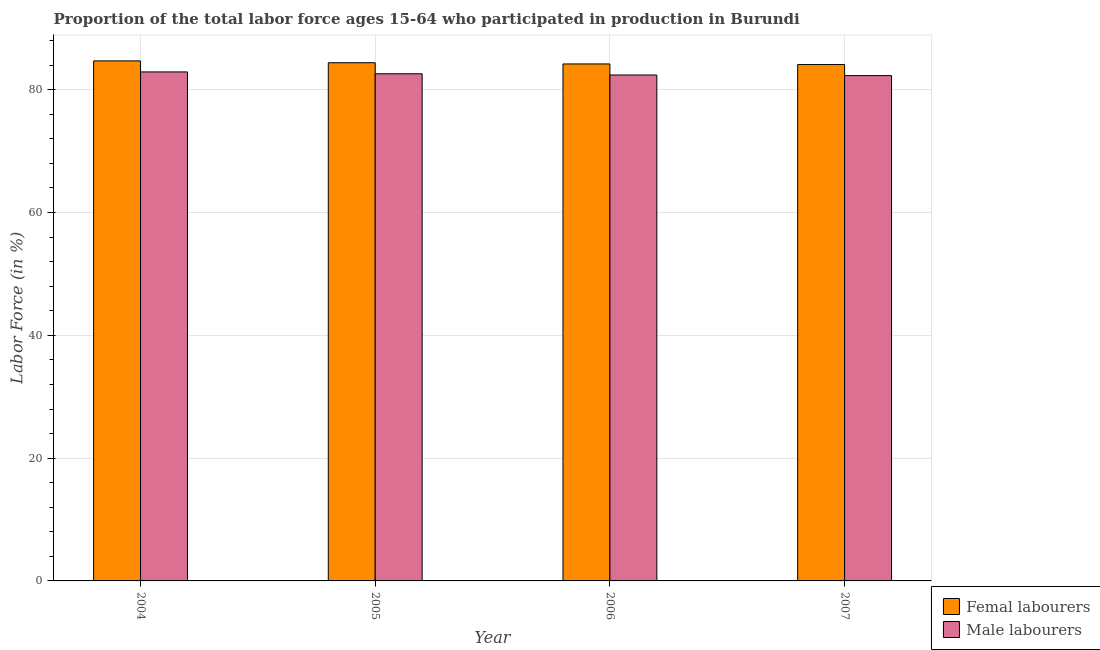Are the number of bars per tick equal to the number of legend labels?
Your answer should be compact. Yes. What is the label of the 4th group of bars from the left?
Provide a succinct answer. 2007. In how many cases, is the number of bars for a given year not equal to the number of legend labels?
Ensure brevity in your answer.  0. What is the percentage of male labour force in 2006?
Your answer should be very brief. 82.4. Across all years, what is the maximum percentage of male labour force?
Your response must be concise. 82.9. Across all years, what is the minimum percentage of female labor force?
Ensure brevity in your answer.  84.1. In which year was the percentage of female labor force maximum?
Your answer should be compact. 2004. What is the total percentage of female labor force in the graph?
Keep it short and to the point. 337.4. What is the difference between the percentage of male labour force in 2004 and that in 2005?
Ensure brevity in your answer.  0.3. What is the difference between the percentage of female labor force in 2006 and the percentage of male labour force in 2004?
Your response must be concise. -0.5. What is the average percentage of female labor force per year?
Ensure brevity in your answer.  84.35. In the year 2007, what is the difference between the percentage of male labour force and percentage of female labor force?
Ensure brevity in your answer.  0. In how many years, is the percentage of female labor force greater than 4 %?
Keep it short and to the point. 4. What is the ratio of the percentage of female labor force in 2004 to that in 2005?
Your response must be concise. 1. Is the percentage of female labor force in 2006 less than that in 2007?
Ensure brevity in your answer.  No. What is the difference between the highest and the second highest percentage of female labor force?
Offer a very short reply. 0.3. What is the difference between the highest and the lowest percentage of female labor force?
Offer a terse response. 0.6. In how many years, is the percentage of male labour force greater than the average percentage of male labour force taken over all years?
Give a very brief answer. 2. Is the sum of the percentage of female labor force in 2004 and 2006 greater than the maximum percentage of male labour force across all years?
Your answer should be compact. Yes. What does the 2nd bar from the left in 2007 represents?
Offer a terse response. Male labourers. What does the 1st bar from the right in 2005 represents?
Your answer should be very brief. Male labourers. How many bars are there?
Your answer should be very brief. 8. Are all the bars in the graph horizontal?
Your answer should be very brief. No. What is the difference between two consecutive major ticks on the Y-axis?
Ensure brevity in your answer.  20. Does the graph contain any zero values?
Ensure brevity in your answer.  No. How are the legend labels stacked?
Your answer should be compact. Vertical. What is the title of the graph?
Give a very brief answer. Proportion of the total labor force ages 15-64 who participated in production in Burundi. Does "Female labourers" appear as one of the legend labels in the graph?
Give a very brief answer. No. What is the label or title of the Y-axis?
Give a very brief answer. Labor Force (in %). What is the Labor Force (in %) of Femal labourers in 2004?
Your answer should be very brief. 84.7. What is the Labor Force (in %) of Male labourers in 2004?
Your answer should be compact. 82.9. What is the Labor Force (in %) in Femal labourers in 2005?
Provide a succinct answer. 84.4. What is the Labor Force (in %) in Male labourers in 2005?
Keep it short and to the point. 82.6. What is the Labor Force (in %) in Femal labourers in 2006?
Keep it short and to the point. 84.2. What is the Labor Force (in %) of Male labourers in 2006?
Your answer should be very brief. 82.4. What is the Labor Force (in %) of Femal labourers in 2007?
Your response must be concise. 84.1. What is the Labor Force (in %) in Male labourers in 2007?
Provide a succinct answer. 82.3. Across all years, what is the maximum Labor Force (in %) of Femal labourers?
Offer a very short reply. 84.7. Across all years, what is the maximum Labor Force (in %) in Male labourers?
Ensure brevity in your answer.  82.9. Across all years, what is the minimum Labor Force (in %) in Femal labourers?
Your response must be concise. 84.1. Across all years, what is the minimum Labor Force (in %) of Male labourers?
Offer a very short reply. 82.3. What is the total Labor Force (in %) in Femal labourers in the graph?
Your response must be concise. 337.4. What is the total Labor Force (in %) in Male labourers in the graph?
Ensure brevity in your answer.  330.2. What is the difference between the Labor Force (in %) of Femal labourers in 2004 and that in 2005?
Offer a very short reply. 0.3. What is the difference between the Labor Force (in %) in Male labourers in 2004 and that in 2005?
Your response must be concise. 0.3. What is the difference between the Labor Force (in %) in Femal labourers in 2004 and that in 2007?
Your response must be concise. 0.6. What is the difference between the Labor Force (in %) in Femal labourers in 2005 and that in 2007?
Your response must be concise. 0.3. What is the difference between the Labor Force (in %) in Male labourers in 2005 and that in 2007?
Give a very brief answer. 0.3. What is the difference between the Labor Force (in %) of Femal labourers in 2006 and that in 2007?
Your answer should be compact. 0.1. What is the difference between the Labor Force (in %) of Femal labourers in 2004 and the Labor Force (in %) of Male labourers in 2005?
Give a very brief answer. 2.1. What is the difference between the Labor Force (in %) of Femal labourers in 2004 and the Labor Force (in %) of Male labourers in 2006?
Make the answer very short. 2.3. What is the difference between the Labor Force (in %) in Femal labourers in 2004 and the Labor Force (in %) in Male labourers in 2007?
Ensure brevity in your answer.  2.4. What is the difference between the Labor Force (in %) in Femal labourers in 2005 and the Labor Force (in %) in Male labourers in 2006?
Offer a terse response. 2. What is the difference between the Labor Force (in %) of Femal labourers in 2005 and the Labor Force (in %) of Male labourers in 2007?
Ensure brevity in your answer.  2.1. What is the difference between the Labor Force (in %) of Femal labourers in 2006 and the Labor Force (in %) of Male labourers in 2007?
Your answer should be compact. 1.9. What is the average Labor Force (in %) in Femal labourers per year?
Ensure brevity in your answer.  84.35. What is the average Labor Force (in %) of Male labourers per year?
Give a very brief answer. 82.55. In the year 2005, what is the difference between the Labor Force (in %) in Femal labourers and Labor Force (in %) in Male labourers?
Your answer should be compact. 1.8. In the year 2006, what is the difference between the Labor Force (in %) of Femal labourers and Labor Force (in %) of Male labourers?
Ensure brevity in your answer.  1.8. What is the ratio of the Labor Force (in %) in Femal labourers in 2004 to that in 2005?
Offer a terse response. 1. What is the ratio of the Labor Force (in %) of Male labourers in 2004 to that in 2005?
Offer a very short reply. 1. What is the ratio of the Labor Force (in %) in Femal labourers in 2004 to that in 2006?
Your response must be concise. 1.01. What is the ratio of the Labor Force (in %) in Femal labourers in 2004 to that in 2007?
Give a very brief answer. 1.01. What is the ratio of the Labor Force (in %) in Male labourers in 2004 to that in 2007?
Offer a very short reply. 1.01. What is the ratio of the Labor Force (in %) in Femal labourers in 2005 to that in 2006?
Provide a succinct answer. 1. What is the ratio of the Labor Force (in %) in Male labourers in 2005 to that in 2006?
Provide a short and direct response. 1. What is the ratio of the Labor Force (in %) in Male labourers in 2005 to that in 2007?
Your response must be concise. 1. What is the ratio of the Labor Force (in %) in Male labourers in 2006 to that in 2007?
Your answer should be compact. 1. What is the difference between the highest and the second highest Labor Force (in %) of Male labourers?
Give a very brief answer. 0.3. What is the difference between the highest and the lowest Labor Force (in %) in Male labourers?
Give a very brief answer. 0.6. 